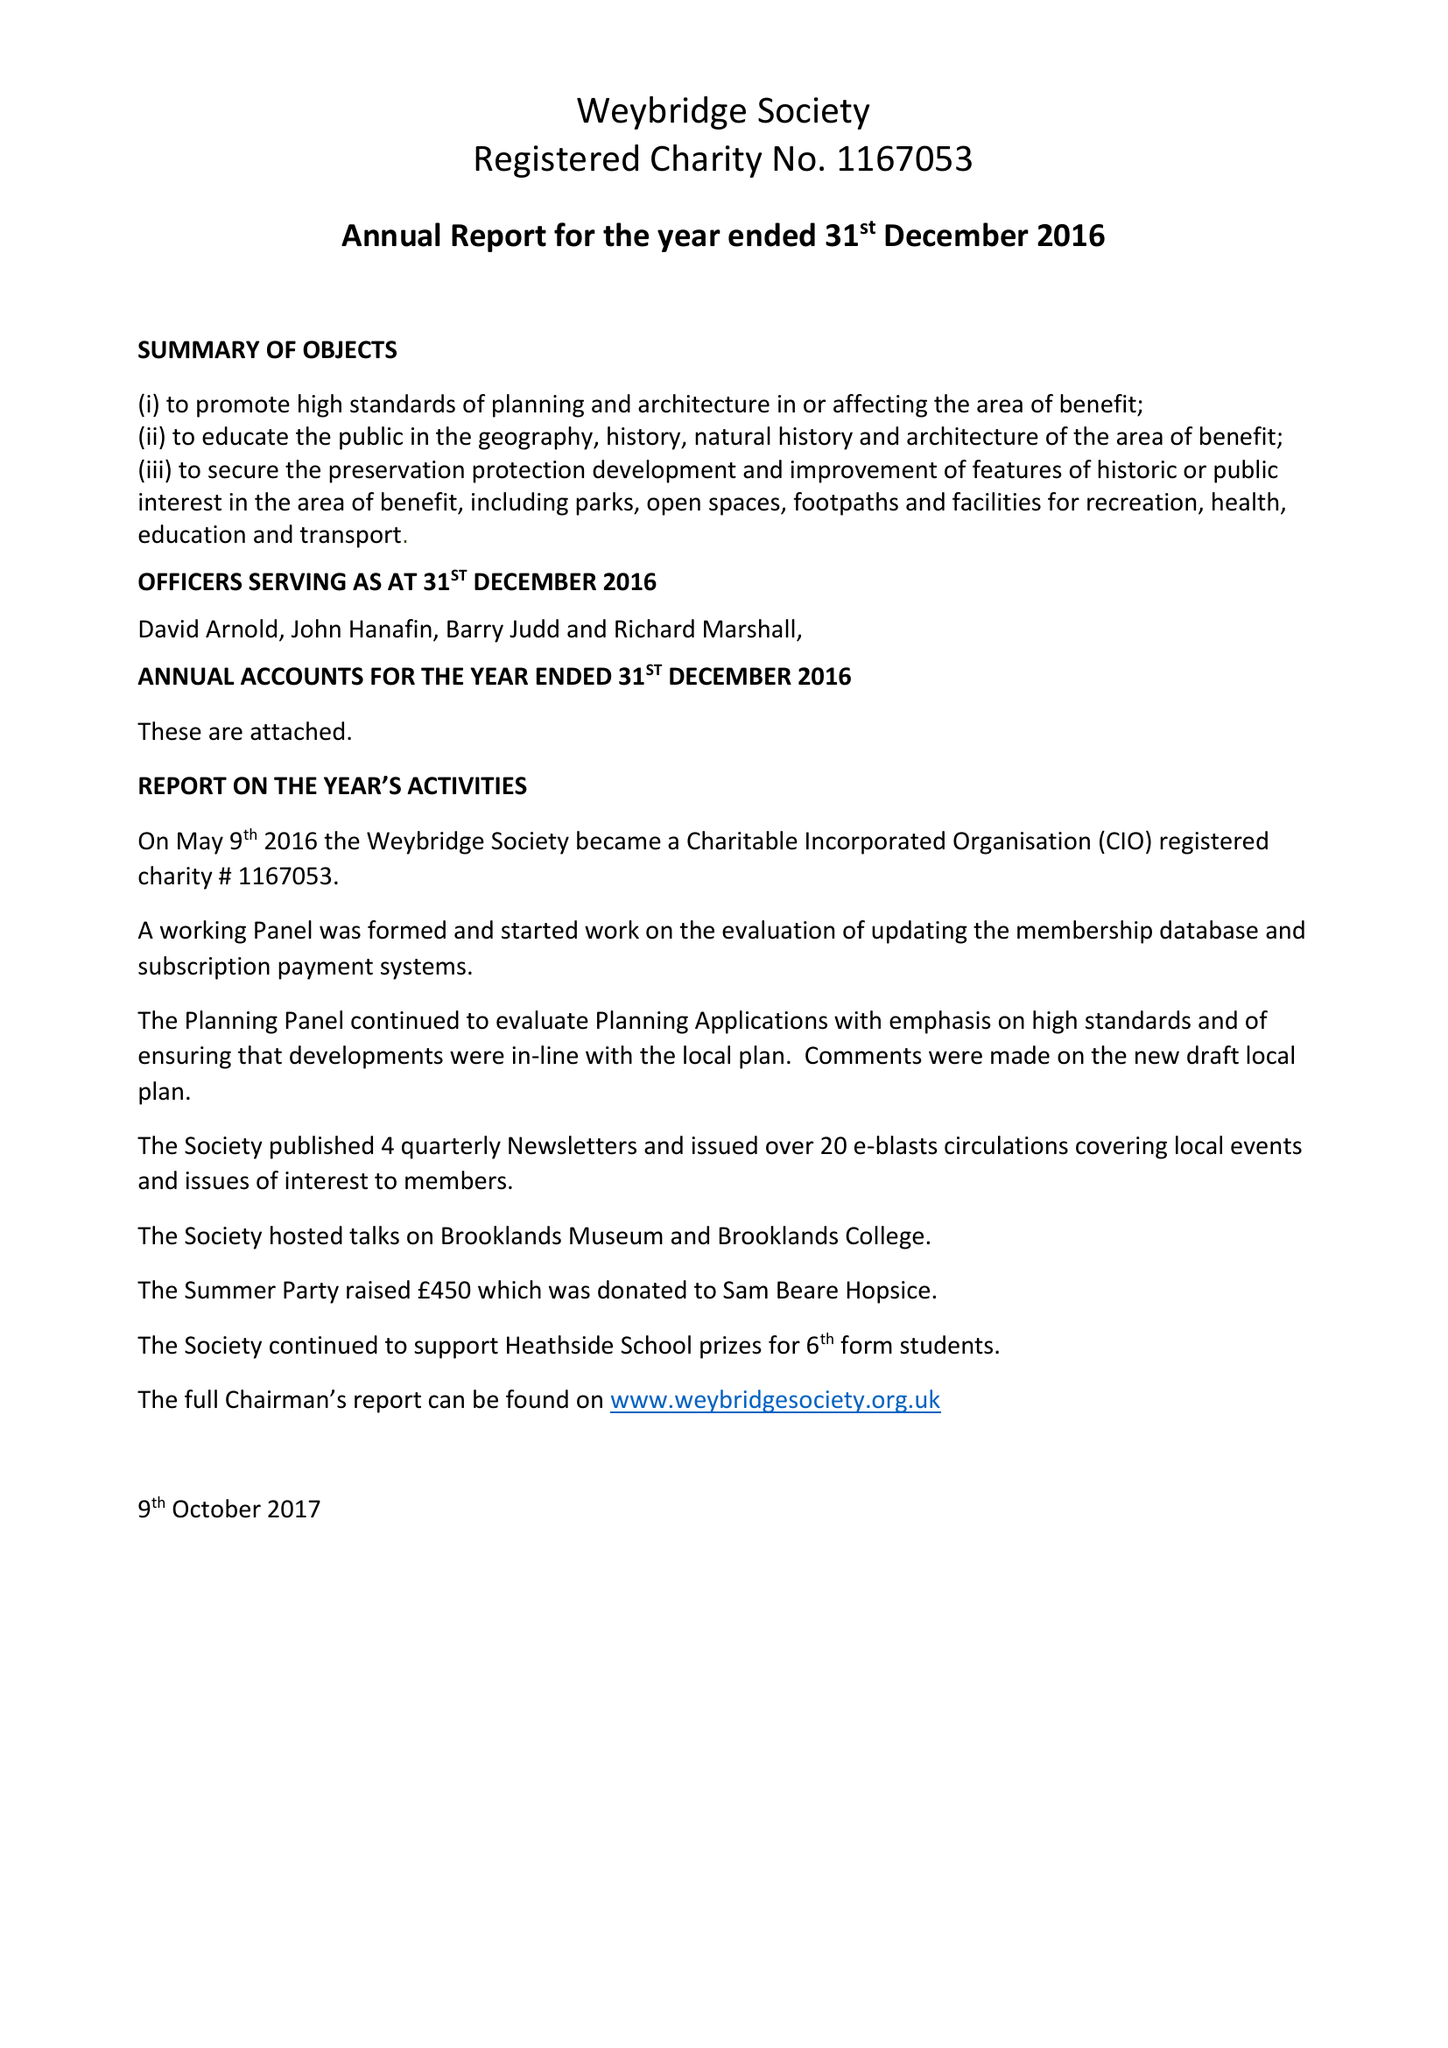What is the value for the address__postcode?
Answer the question using a single word or phrase. None 